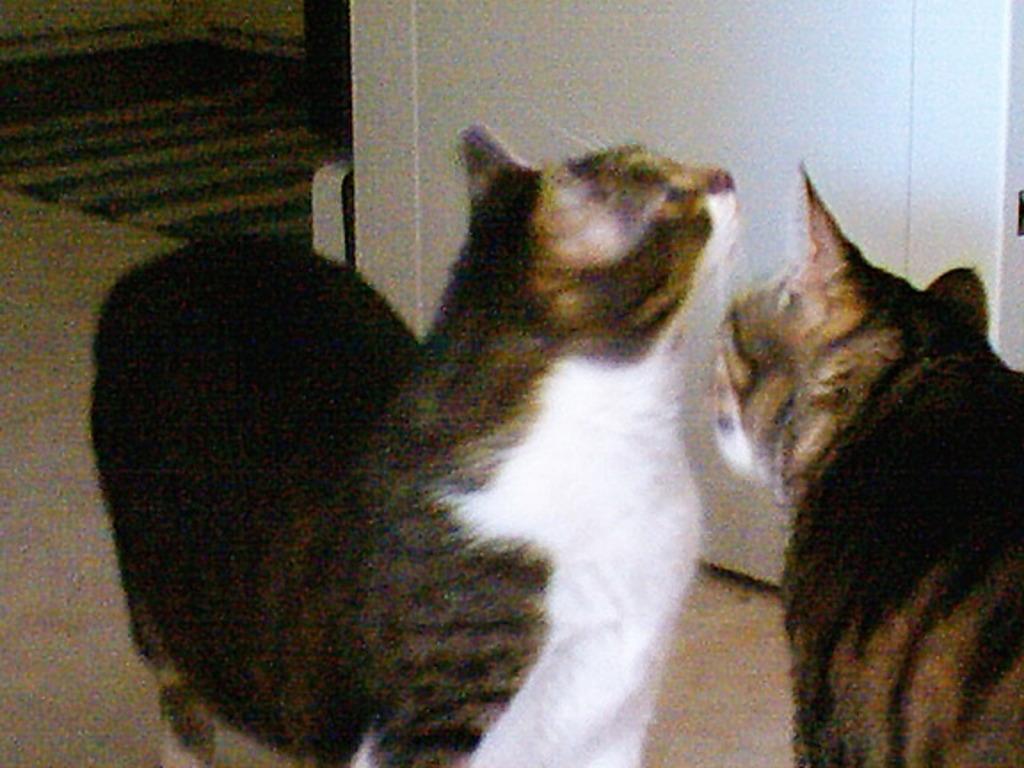Can you describe this image briefly? In the center of the image there are two cats. There is a door. At the bottom of the image there is a carpet. 